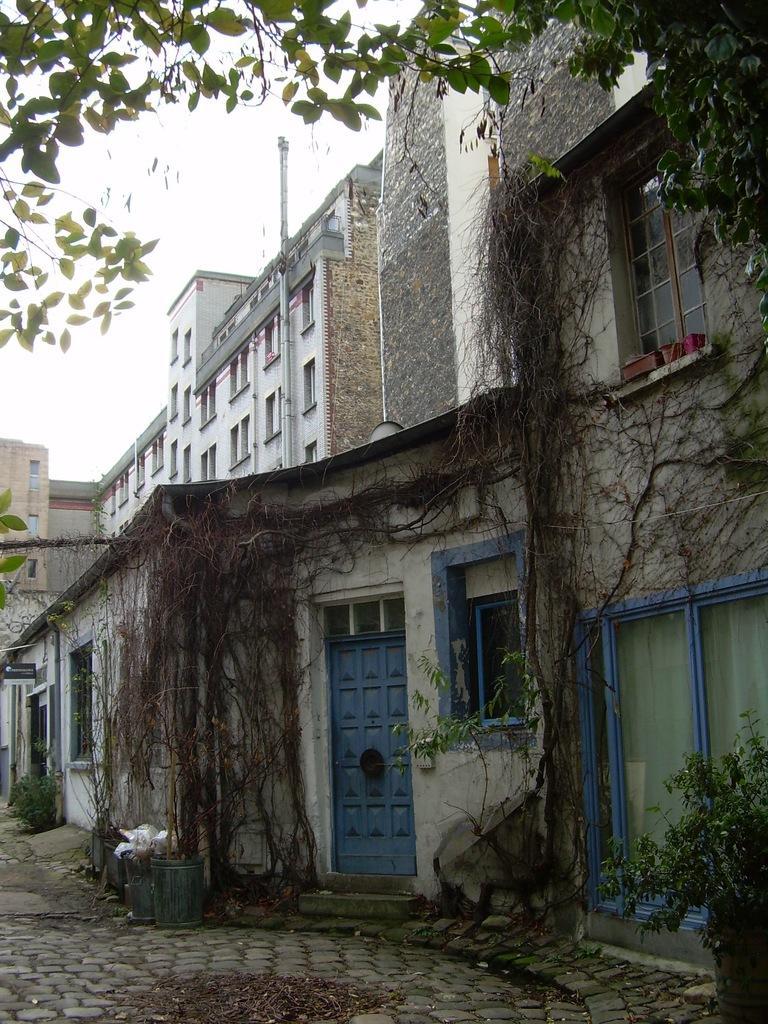How would you summarize this image in a sentence or two? At the bottom of this image I can see the ground. There are some buildings. On the top of the image I can see the leaves of a tree. On the right side, I can see a plant on the ground. 